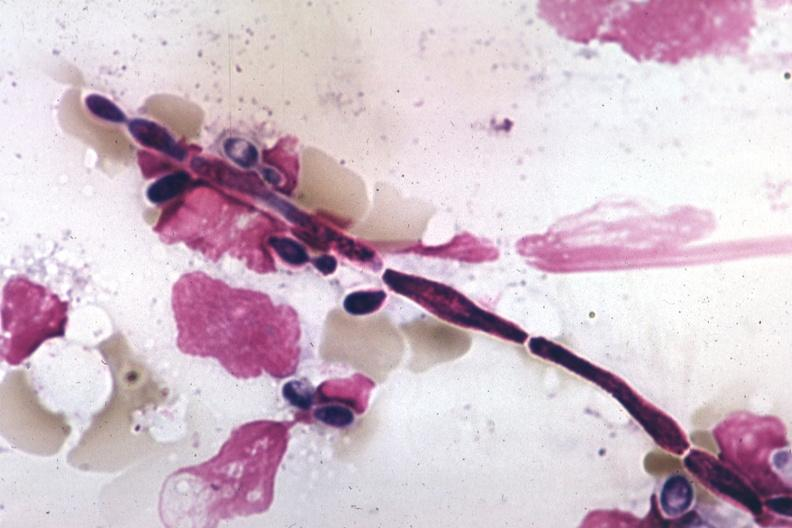s candida in peripheral blood present?
Answer the question using a single word or phrase. Yes 